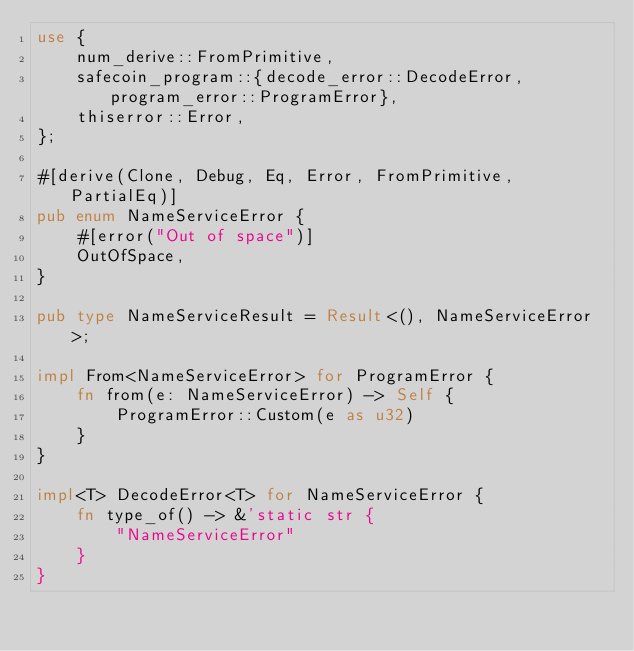<code> <loc_0><loc_0><loc_500><loc_500><_Rust_>use {
    num_derive::FromPrimitive,
    safecoin_program::{decode_error::DecodeError, program_error::ProgramError},
    thiserror::Error,
};

#[derive(Clone, Debug, Eq, Error, FromPrimitive, PartialEq)]
pub enum NameServiceError {
    #[error("Out of space")]
    OutOfSpace,
}

pub type NameServiceResult = Result<(), NameServiceError>;

impl From<NameServiceError> for ProgramError {
    fn from(e: NameServiceError) -> Self {
        ProgramError::Custom(e as u32)
    }
}

impl<T> DecodeError<T> for NameServiceError {
    fn type_of() -> &'static str {
        "NameServiceError"
    }
}
</code> 